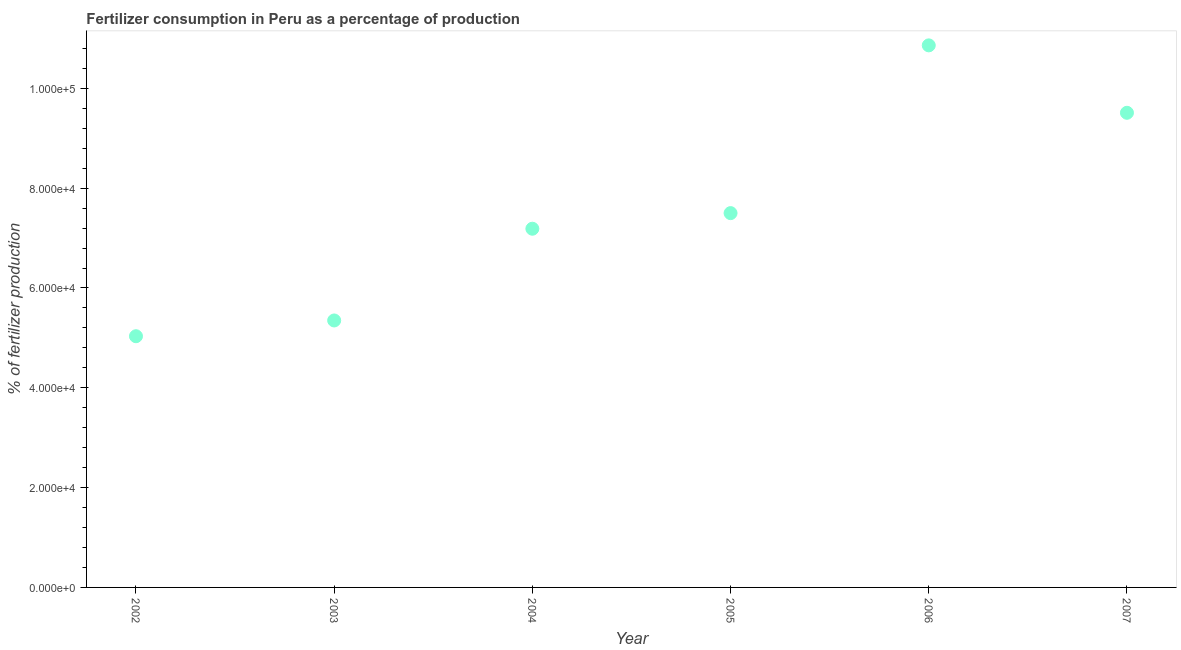What is the amount of fertilizer consumption in 2006?
Offer a terse response. 1.09e+05. Across all years, what is the maximum amount of fertilizer consumption?
Provide a short and direct response. 1.09e+05. Across all years, what is the minimum amount of fertilizer consumption?
Give a very brief answer. 5.03e+04. In which year was the amount of fertilizer consumption maximum?
Keep it short and to the point. 2006. In which year was the amount of fertilizer consumption minimum?
Your response must be concise. 2002. What is the sum of the amount of fertilizer consumption?
Make the answer very short. 4.54e+05. What is the difference between the amount of fertilizer consumption in 2002 and 2005?
Keep it short and to the point. -2.47e+04. What is the average amount of fertilizer consumption per year?
Your answer should be compact. 7.57e+04. What is the median amount of fertilizer consumption?
Provide a succinct answer. 7.34e+04. Do a majority of the years between 2006 and 2005 (inclusive) have amount of fertilizer consumption greater than 104000 %?
Offer a very short reply. No. What is the ratio of the amount of fertilizer consumption in 2004 to that in 2007?
Ensure brevity in your answer.  0.76. Is the amount of fertilizer consumption in 2004 less than that in 2006?
Keep it short and to the point. Yes. Is the difference between the amount of fertilizer consumption in 2002 and 2004 greater than the difference between any two years?
Your answer should be compact. No. What is the difference between the highest and the second highest amount of fertilizer consumption?
Provide a short and direct response. 1.35e+04. Is the sum of the amount of fertilizer consumption in 2002 and 2007 greater than the maximum amount of fertilizer consumption across all years?
Keep it short and to the point. Yes. What is the difference between the highest and the lowest amount of fertilizer consumption?
Make the answer very short. 5.83e+04. In how many years, is the amount of fertilizer consumption greater than the average amount of fertilizer consumption taken over all years?
Provide a succinct answer. 2. Does the amount of fertilizer consumption monotonically increase over the years?
Your answer should be very brief. No. How many years are there in the graph?
Provide a short and direct response. 6. Are the values on the major ticks of Y-axis written in scientific E-notation?
Offer a very short reply. Yes. What is the title of the graph?
Provide a short and direct response. Fertilizer consumption in Peru as a percentage of production. What is the label or title of the X-axis?
Make the answer very short. Year. What is the label or title of the Y-axis?
Your answer should be compact. % of fertilizer production. What is the % of fertilizer production in 2002?
Keep it short and to the point. 5.03e+04. What is the % of fertilizer production in 2003?
Make the answer very short. 5.35e+04. What is the % of fertilizer production in 2004?
Make the answer very short. 7.19e+04. What is the % of fertilizer production in 2005?
Make the answer very short. 7.50e+04. What is the % of fertilizer production in 2006?
Give a very brief answer. 1.09e+05. What is the % of fertilizer production in 2007?
Offer a very short reply. 9.51e+04. What is the difference between the % of fertilizer production in 2002 and 2003?
Keep it short and to the point. -3157.12. What is the difference between the % of fertilizer production in 2002 and 2004?
Your answer should be compact. -2.15e+04. What is the difference between the % of fertilizer production in 2002 and 2005?
Ensure brevity in your answer.  -2.47e+04. What is the difference between the % of fertilizer production in 2002 and 2006?
Ensure brevity in your answer.  -5.83e+04. What is the difference between the % of fertilizer production in 2002 and 2007?
Provide a succinct answer. -4.48e+04. What is the difference between the % of fertilizer production in 2003 and 2004?
Provide a succinct answer. -1.84e+04. What is the difference between the % of fertilizer production in 2003 and 2005?
Your answer should be compact. -2.15e+04. What is the difference between the % of fertilizer production in 2003 and 2006?
Keep it short and to the point. -5.51e+04. What is the difference between the % of fertilizer production in 2003 and 2007?
Make the answer very short. -4.16e+04. What is the difference between the % of fertilizer production in 2004 and 2005?
Offer a terse response. -3126.98. What is the difference between the % of fertilizer production in 2004 and 2006?
Offer a very short reply. -3.67e+04. What is the difference between the % of fertilizer production in 2004 and 2007?
Give a very brief answer. -2.32e+04. What is the difference between the % of fertilizer production in 2005 and 2006?
Ensure brevity in your answer.  -3.36e+04. What is the difference between the % of fertilizer production in 2005 and 2007?
Provide a succinct answer. -2.01e+04. What is the difference between the % of fertilizer production in 2006 and 2007?
Your answer should be compact. 1.35e+04. What is the ratio of the % of fertilizer production in 2002 to that in 2003?
Provide a short and direct response. 0.94. What is the ratio of the % of fertilizer production in 2002 to that in 2004?
Provide a succinct answer. 0.7. What is the ratio of the % of fertilizer production in 2002 to that in 2005?
Your answer should be compact. 0.67. What is the ratio of the % of fertilizer production in 2002 to that in 2006?
Your response must be concise. 0.46. What is the ratio of the % of fertilizer production in 2002 to that in 2007?
Keep it short and to the point. 0.53. What is the ratio of the % of fertilizer production in 2003 to that in 2004?
Your response must be concise. 0.74. What is the ratio of the % of fertilizer production in 2003 to that in 2005?
Make the answer very short. 0.71. What is the ratio of the % of fertilizer production in 2003 to that in 2006?
Your response must be concise. 0.49. What is the ratio of the % of fertilizer production in 2003 to that in 2007?
Offer a very short reply. 0.56. What is the ratio of the % of fertilizer production in 2004 to that in 2005?
Make the answer very short. 0.96. What is the ratio of the % of fertilizer production in 2004 to that in 2006?
Offer a terse response. 0.66. What is the ratio of the % of fertilizer production in 2004 to that in 2007?
Offer a terse response. 0.76. What is the ratio of the % of fertilizer production in 2005 to that in 2006?
Offer a very short reply. 0.69. What is the ratio of the % of fertilizer production in 2005 to that in 2007?
Make the answer very short. 0.79. What is the ratio of the % of fertilizer production in 2006 to that in 2007?
Give a very brief answer. 1.14. 